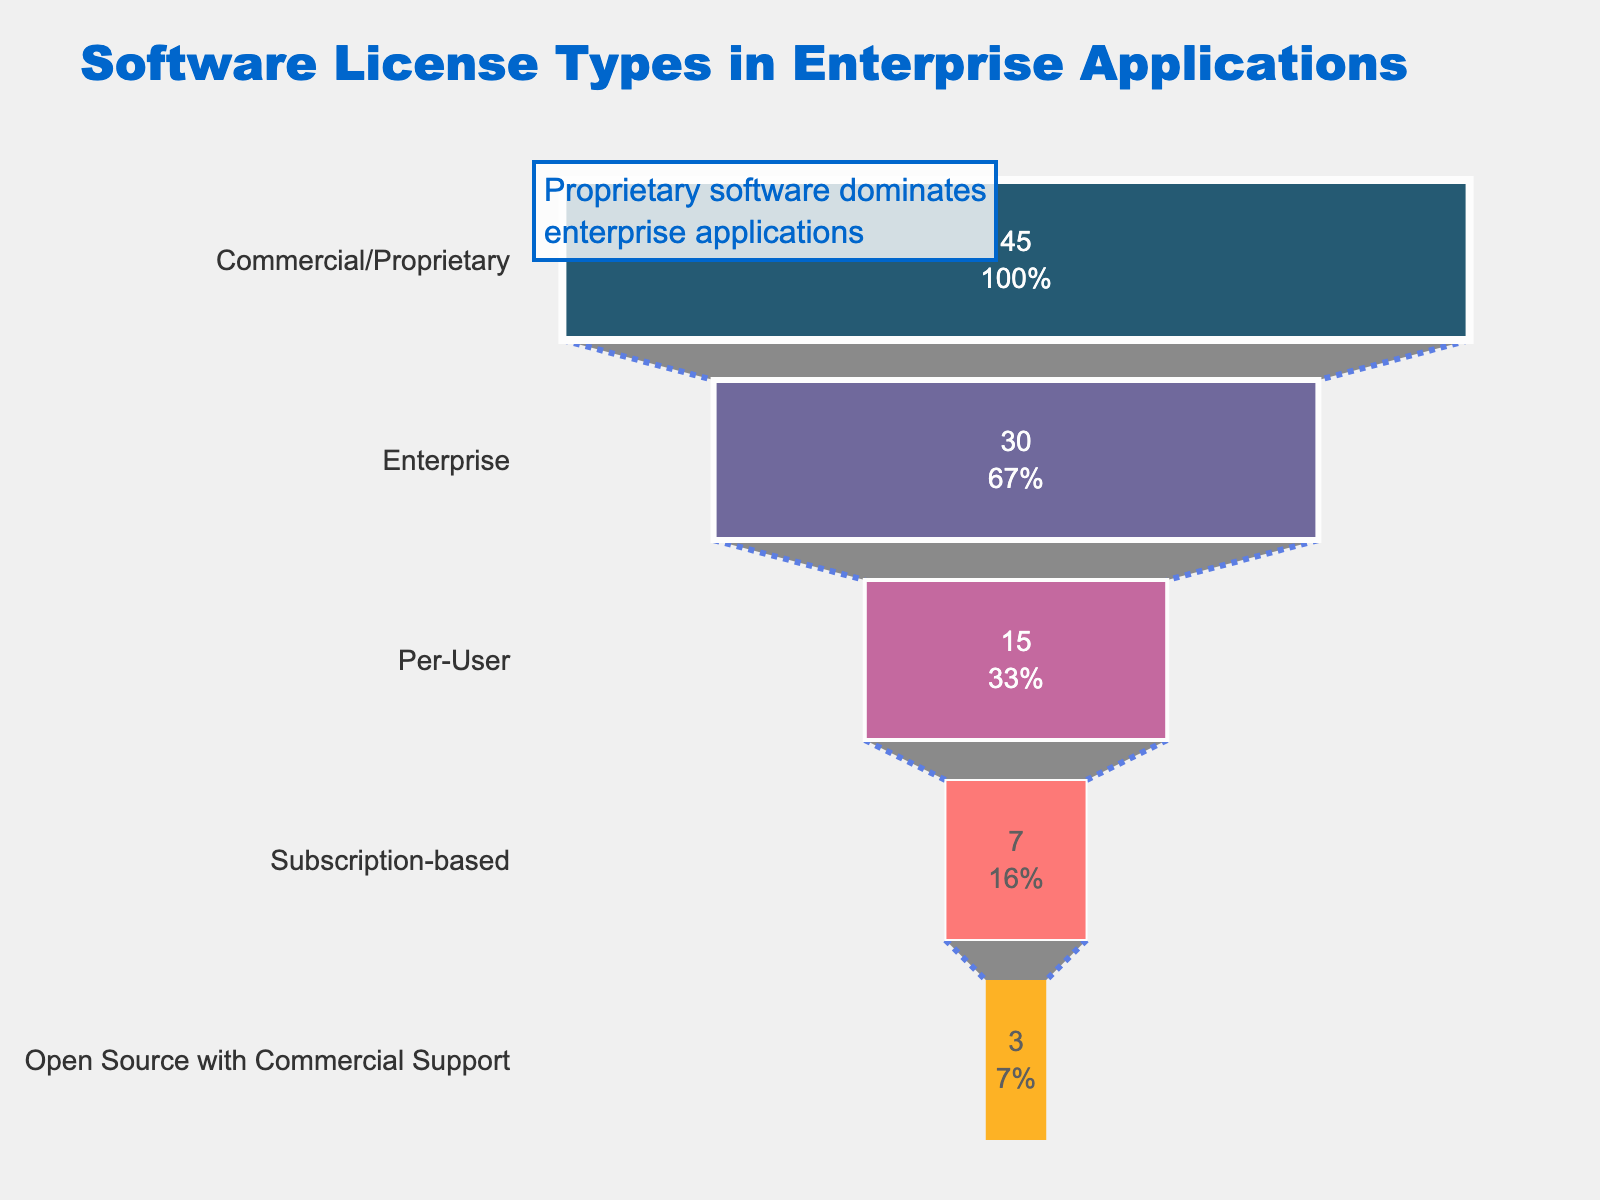What is the title of the funnel chart? The title is positioned at the top of the chart and provides a summary of what the chart represents.
Answer: Software License Types in Enterprise Applications Which license type has the highest prevalence? The chart shows the largest section at the top, which indicates the highest percentage.
Answer: Commercial/Proprietary What is the prevalence percentage of the Subscription-based license type? Locate the Subscription-based section on the chart and refer to the percentage labeled inside this section.
Answer: 7% How does the prevalence of the Enterprise license type compare to Commercial/Proprietary? Compare the percentages given for the Enterprise and Commercial/Proprietary sections.
Answer: Commercial/Proprietary is 15% higher What is the cumulative prevalence of Per-User and Subscription-based license types? Add the percentages of Per-User and Subscription-based license types shown in their respective sections.
Answer: 22% What percentage of enterprises use Open Source with Commercial Support? Locate the Open Source with Commercial Support section and refer to the percentage labeled inside.
Answer: 3% How much more prevalent is the Commercial/Proprietary license type compared to the least prevalent type? Subtract the percentage of the least prevalent type (Open Source with Commercial Support) from the percentage of the most prevalent type (Commercial/Proprietary).
Answer: 42% Which license types have a prevalence greater than 10%? Identify the sections with percentages greater than 10%.
Answer: Commercial/Proprietary, Enterprise, Per-User What is the difference in prevalence between Per-User and Enterprise licenses? Subtract the percentage of the Per-User license from the percentage of the Enterprise license.
Answer: 15% How many types of license models are depicted in the chart? Count the distinct sections or labels representing different license types.
Answer: 5 